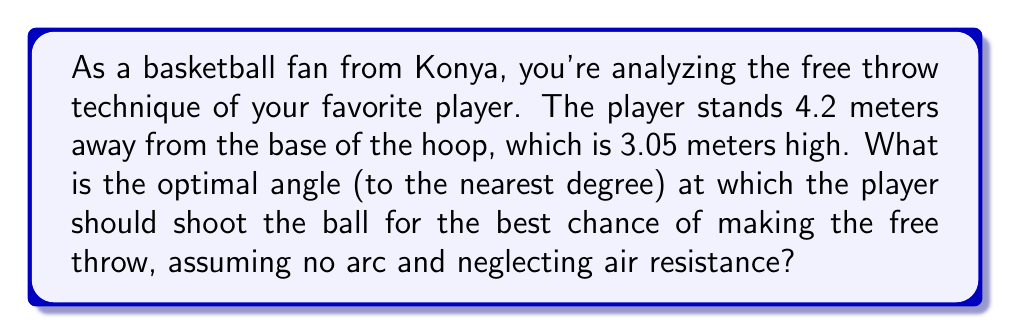Provide a solution to this math problem. Let's approach this step-by-step:

1) First, we need to visualize the problem. The player, the base of the hoop, and the top of the hoop form a right triangle.

[asy]
import geometry;

pair A = (0,0);
pair B = (4.2,0);
pair C = (4.2,3.05);

draw(A--B--C--A);

label("Player", A, SW);
label("Base of hoop", B, SE);
label("Top of hoop", C, NE);

label("4.2 m", (A+B)/2, S);
label("3.05 m", (B+C)/2, E);

draw(A--C,dashed);
label("$\theta$", (0.5,0), NW);
[/asy]

2) We're looking for the angle $\theta$ that the ball's trajectory makes with the horizontal.

3) In this right triangle:
   - The adjacent side to $\theta$ is 4.2 meters (distance to hoop)
   - The opposite side to $\theta$ is 3.05 meters (height of hoop)

4) We can use the arctangent function to find this angle:

   $$\theta = \arctan(\frac{\text{opposite}}{\text{adjacent}}) = \arctan(\frac{3.05}{4.2})$$

5) Let's calculate:
   $$\theta = \arctan(\frac{3.05}{4.2}) \approx 0.6277 \text{ radians}$$

6) Convert to degrees:
   $$\theta \approx 0.6277 \times \frac{180}{\pi} \approx 35.96°$$

7) Rounding to the nearest degree:
   $$\theta \approx 36°$$

Therefore, the optimal angle for the free throw shot is approximately 36 degrees.
Answer: 36° 